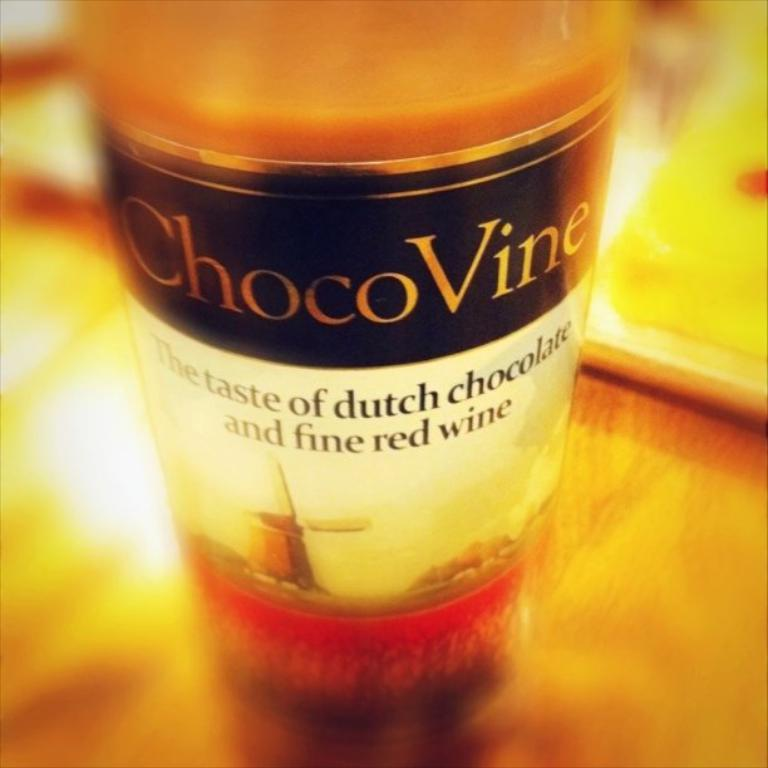What is the main subject of the picture? The main subject of the picture is a choko vine bottle. Where is the choko vine bottle located in the image? The bottle is on a table. What type of cloth is draped over the choko vine bottle in the image? There is no cloth draped over the choko vine bottle in the image. What angle is the choko vine bottle positioned at in the image? The angle at which the choko vine bottle is positioned cannot be determined from the image. How many lizards are visible on the table in the image? There are no lizards present in the image. 